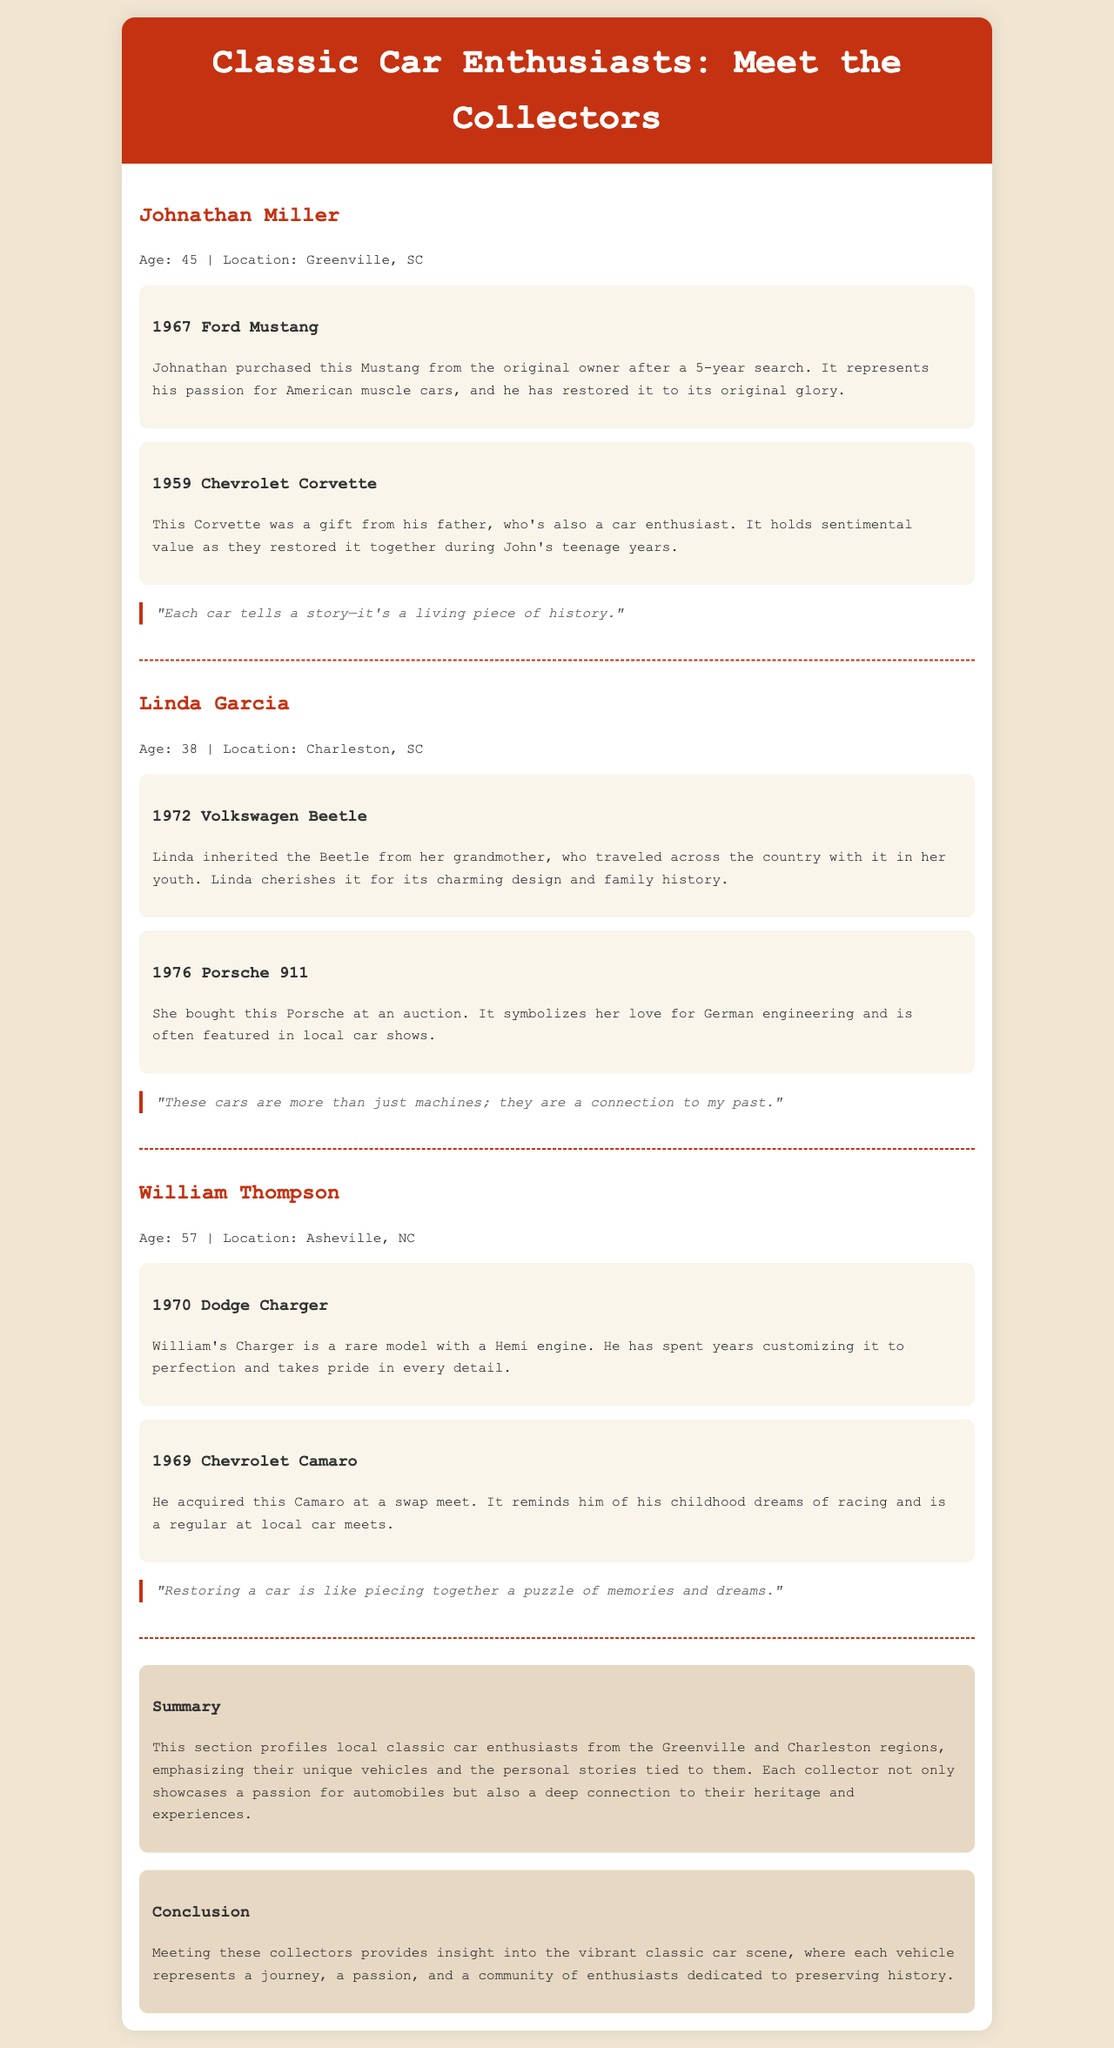What is Johnathan's age? Johnathan's age is stated in the document as part of his profile.
Answer: 45 Where is Linda Garcia from? The location of Linda Garcia is included in her personal information section.
Answer: Charleston, SC What model is William Thompson's rare car? The document mentions that William has a rare Dodge Charger with a Hemi engine.
Answer: Dodge Charger What does Johnathan's Corvette represent? The reason why Johnathan values his Corvette is explained in a personal story related to his father.
Answer: Sentimental value How many cars does each collector showcase? Each collector features two cars in their profile, as outlined in the document structure.
Answer: Two What common theme do the quotes from each collector share? The quotes reflect a deeper sentiment connected to their vehicles, tying into the document's emphasis on personal stories.
Answer: Connection to history What geographical areas are highlighted in the report? The document specifically mentions the locations of the collectors, indicating the regions covered.
Answer: Greenville and Charleston What type of report is this document categorized as? The overall structure and content categorize this document as a profile or highlight of local enthusiasts.
Answer: Report on classic car collectors 